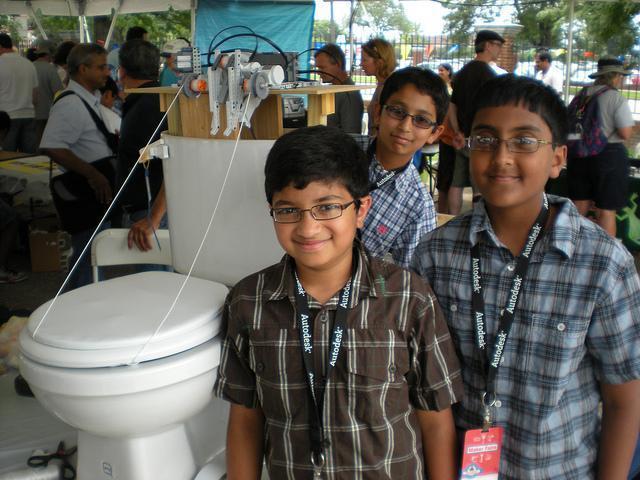How many toilets are there?
Give a very brief answer. 1. How many people are there?
Give a very brief answer. 9. How many people are standing to the left of the open train door?
Give a very brief answer. 0. 